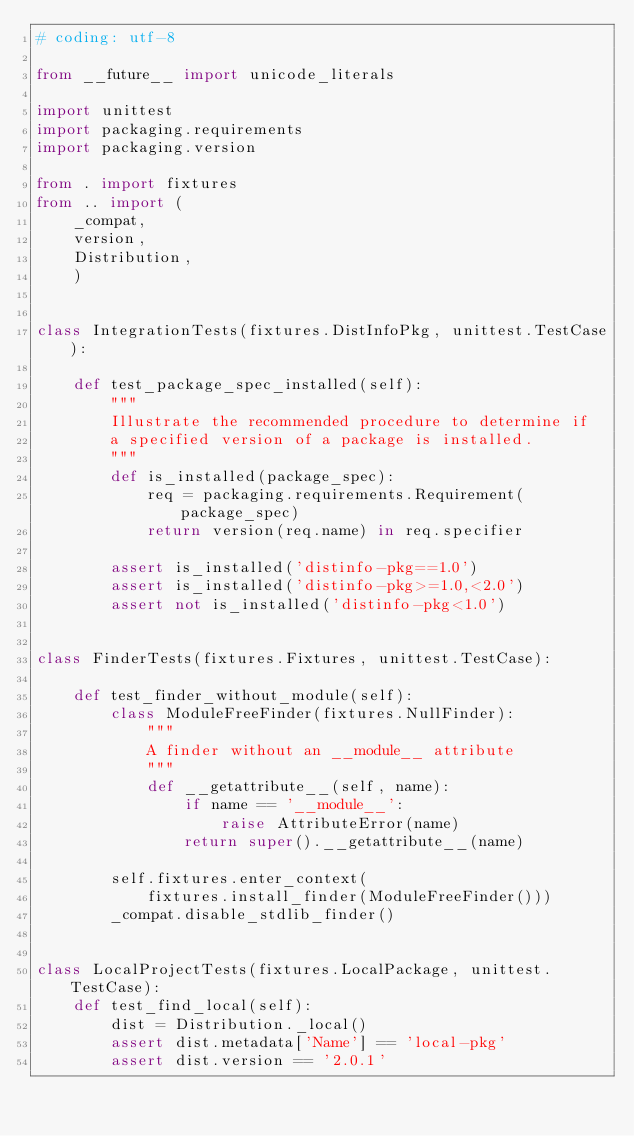<code> <loc_0><loc_0><loc_500><loc_500><_Python_># coding: utf-8

from __future__ import unicode_literals

import unittest
import packaging.requirements
import packaging.version

from . import fixtures
from .. import (
    _compat,
    version,
    Distribution,
    )


class IntegrationTests(fixtures.DistInfoPkg, unittest.TestCase):

    def test_package_spec_installed(self):
        """
        Illustrate the recommended procedure to determine if
        a specified version of a package is installed.
        """
        def is_installed(package_spec):
            req = packaging.requirements.Requirement(package_spec)
            return version(req.name) in req.specifier

        assert is_installed('distinfo-pkg==1.0')
        assert is_installed('distinfo-pkg>=1.0,<2.0')
        assert not is_installed('distinfo-pkg<1.0')


class FinderTests(fixtures.Fixtures, unittest.TestCase):

    def test_finder_without_module(self):
        class ModuleFreeFinder(fixtures.NullFinder):
            """
            A finder without an __module__ attribute
            """
            def __getattribute__(self, name):
                if name == '__module__':
                    raise AttributeError(name)
                return super().__getattribute__(name)

        self.fixtures.enter_context(
            fixtures.install_finder(ModuleFreeFinder()))
        _compat.disable_stdlib_finder()


class LocalProjectTests(fixtures.LocalPackage, unittest.TestCase):
    def test_find_local(self):
        dist = Distribution._local()
        assert dist.metadata['Name'] == 'local-pkg'
        assert dist.version == '2.0.1'
</code> 